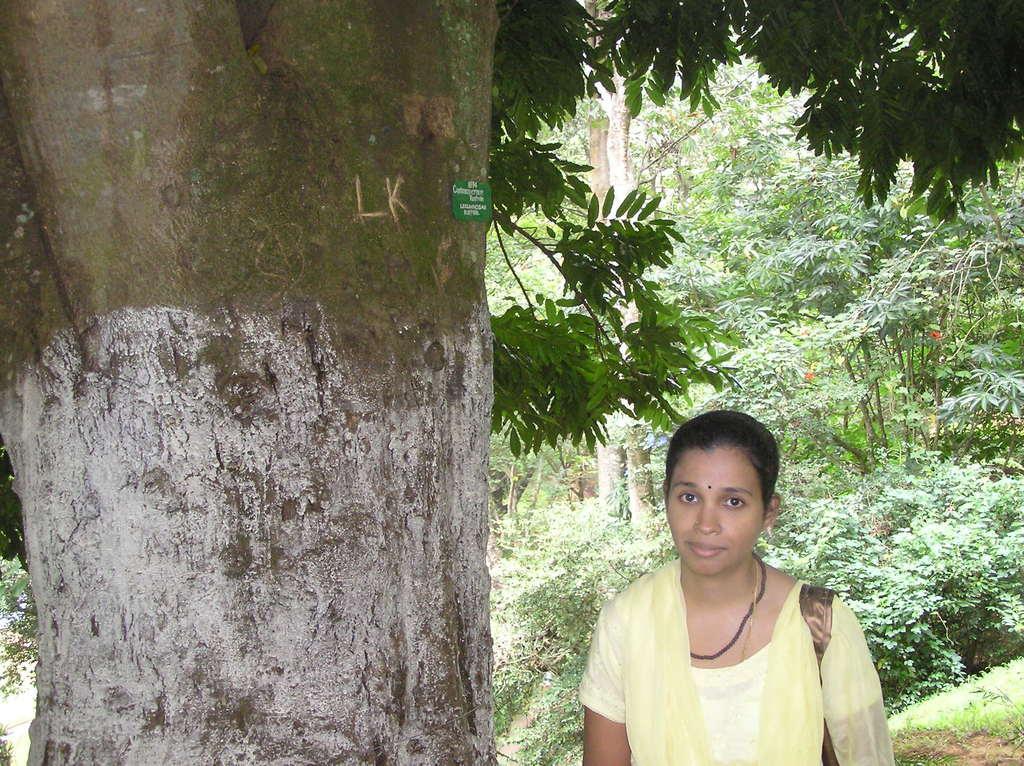In one or two sentences, can you explain what this image depicts? There are many trees in the image. A lady is standing and carrying an object. 